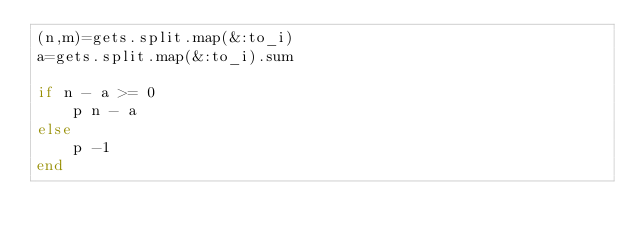Convert code to text. <code><loc_0><loc_0><loc_500><loc_500><_Ruby_>(n,m)=gets.split.map(&:to_i)
a=gets.split.map(&:to_i).sum

if n - a >= 0
    p n - a
else
    p -1
end

</code> 